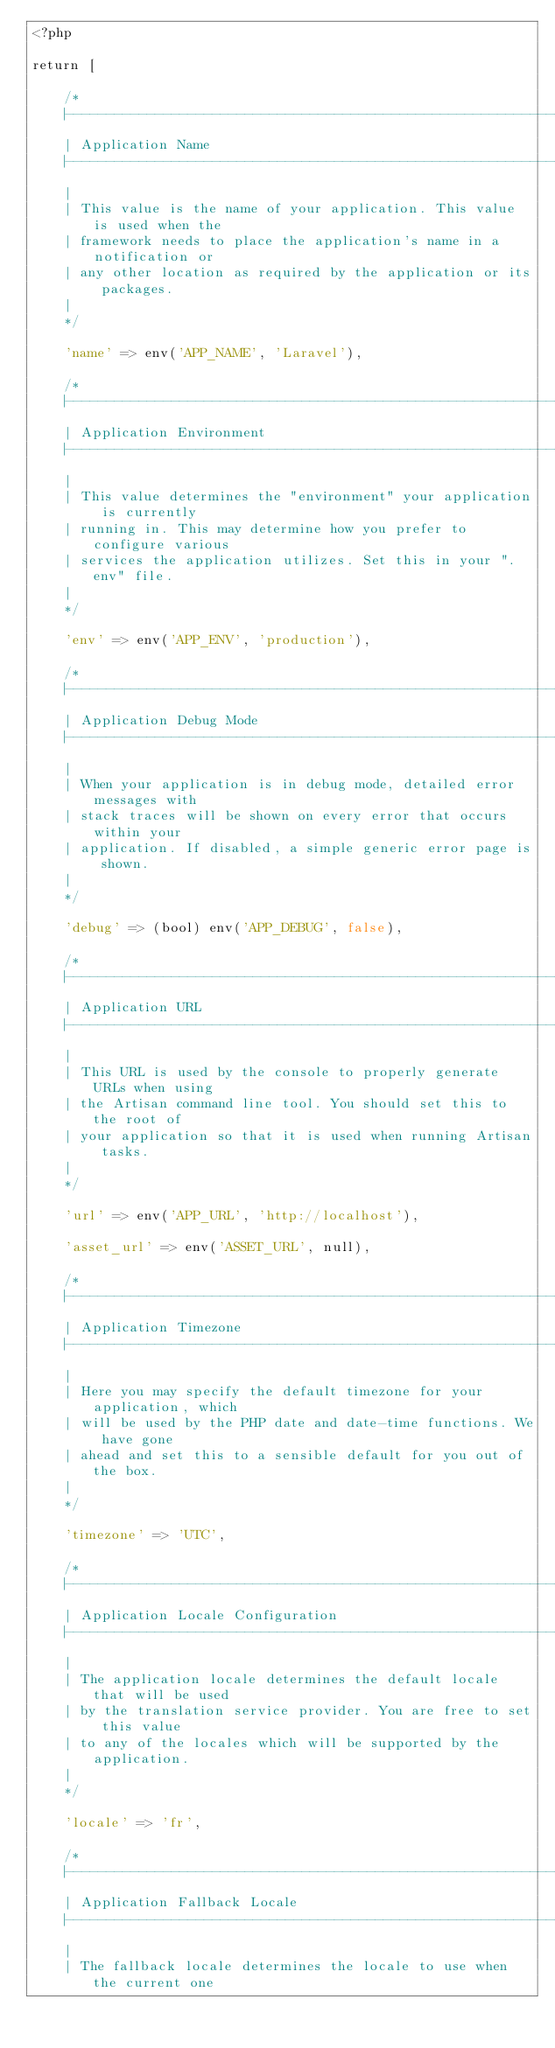<code> <loc_0><loc_0><loc_500><loc_500><_PHP_><?php

return [

    /*
    |--------------------------------------------------------------------------
    | Application Name
    |--------------------------------------------------------------------------
    |
    | This value is the name of your application. This value is used when the
    | framework needs to place the application's name in a notification or
    | any other location as required by the application or its packages.
    |
    */

    'name' => env('APP_NAME', 'Laravel'),

    /*
    |--------------------------------------------------------------------------
    | Application Environment
    |--------------------------------------------------------------------------
    |
    | This value determines the "environment" your application is currently
    | running in. This may determine how you prefer to configure various
    | services the application utilizes. Set this in your ".env" file.
    |
    */

    'env' => env('APP_ENV', 'production'),

    /*
    |--------------------------------------------------------------------------
    | Application Debug Mode
    |--------------------------------------------------------------------------
    |
    | When your application is in debug mode, detailed error messages with
    | stack traces will be shown on every error that occurs within your
    | application. If disabled, a simple generic error page is shown.
    |
    */

    'debug' => (bool) env('APP_DEBUG', false),

    /*
    |--------------------------------------------------------------------------
    | Application URL
    |--------------------------------------------------------------------------
    |
    | This URL is used by the console to properly generate URLs when using
    | the Artisan command line tool. You should set this to the root of
    | your application so that it is used when running Artisan tasks.
    |
    */

    'url' => env('APP_URL', 'http://localhost'),

    'asset_url' => env('ASSET_URL', null),

    /*
    |--------------------------------------------------------------------------
    | Application Timezone
    |--------------------------------------------------------------------------
    |
    | Here you may specify the default timezone for your application, which
    | will be used by the PHP date and date-time functions. We have gone
    | ahead and set this to a sensible default for you out of the box.
    |
    */

    'timezone' => 'UTC',

    /*
    |--------------------------------------------------------------------------
    | Application Locale Configuration
    |--------------------------------------------------------------------------
    |
    | The application locale determines the default locale that will be used
    | by the translation service provider. You are free to set this value
    | to any of the locales which will be supported by the application.
    |
    */

    'locale' => 'fr',

    /*
    |--------------------------------------------------------------------------
    | Application Fallback Locale
    |--------------------------------------------------------------------------
    |
    | The fallback locale determines the locale to use when the current one</code> 